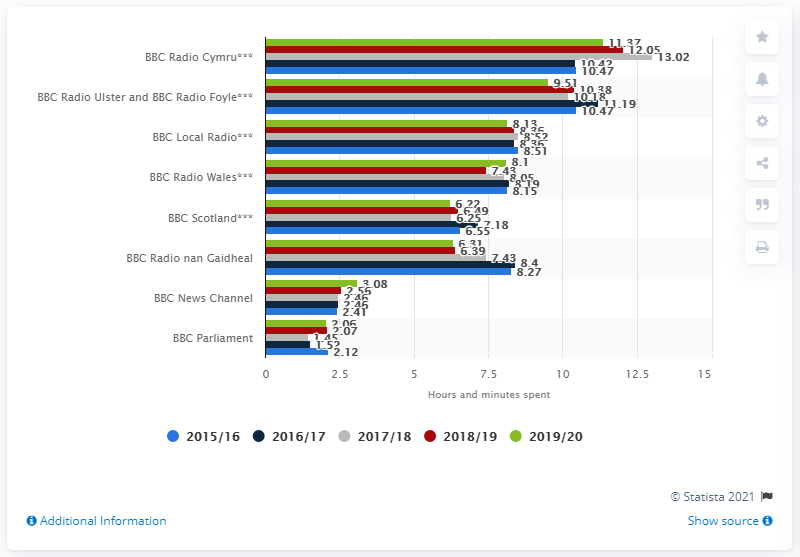List a handful of essential elements in this visual. In 2019/20, audiences spent the most time listening to BBC Radio Cymru. 